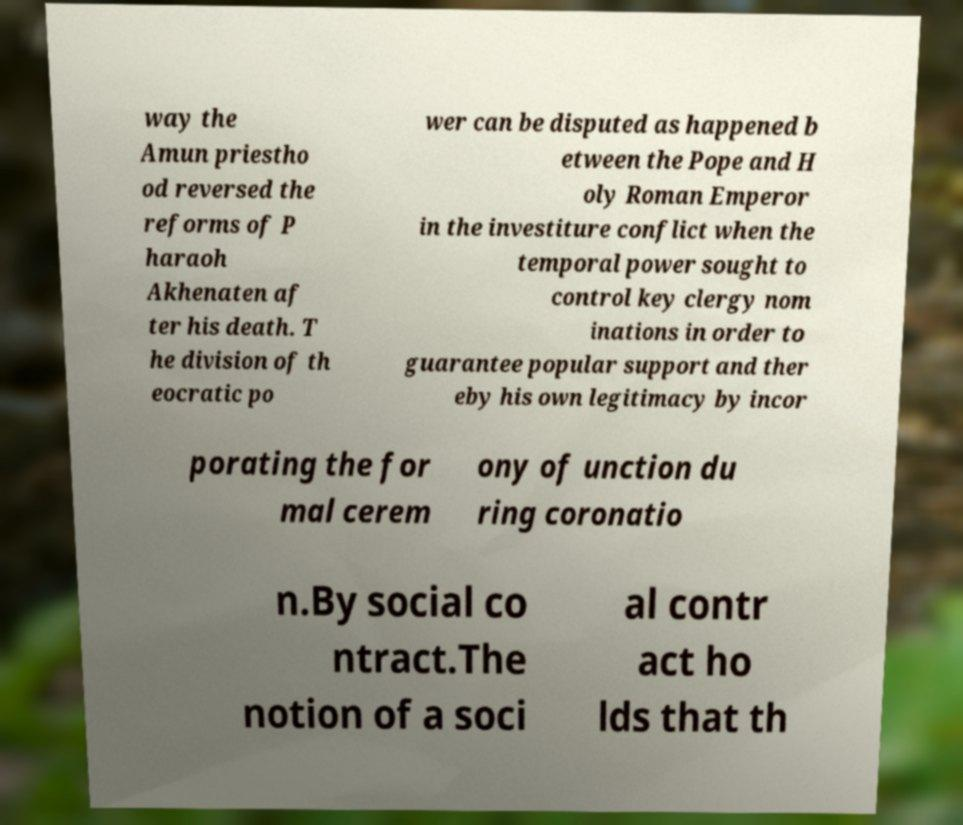Please identify and transcribe the text found in this image. way the Amun priestho od reversed the reforms of P haraoh Akhenaten af ter his death. T he division of th eocratic po wer can be disputed as happened b etween the Pope and H oly Roman Emperor in the investiture conflict when the temporal power sought to control key clergy nom inations in order to guarantee popular support and ther eby his own legitimacy by incor porating the for mal cerem ony of unction du ring coronatio n.By social co ntract.The notion of a soci al contr act ho lds that th 